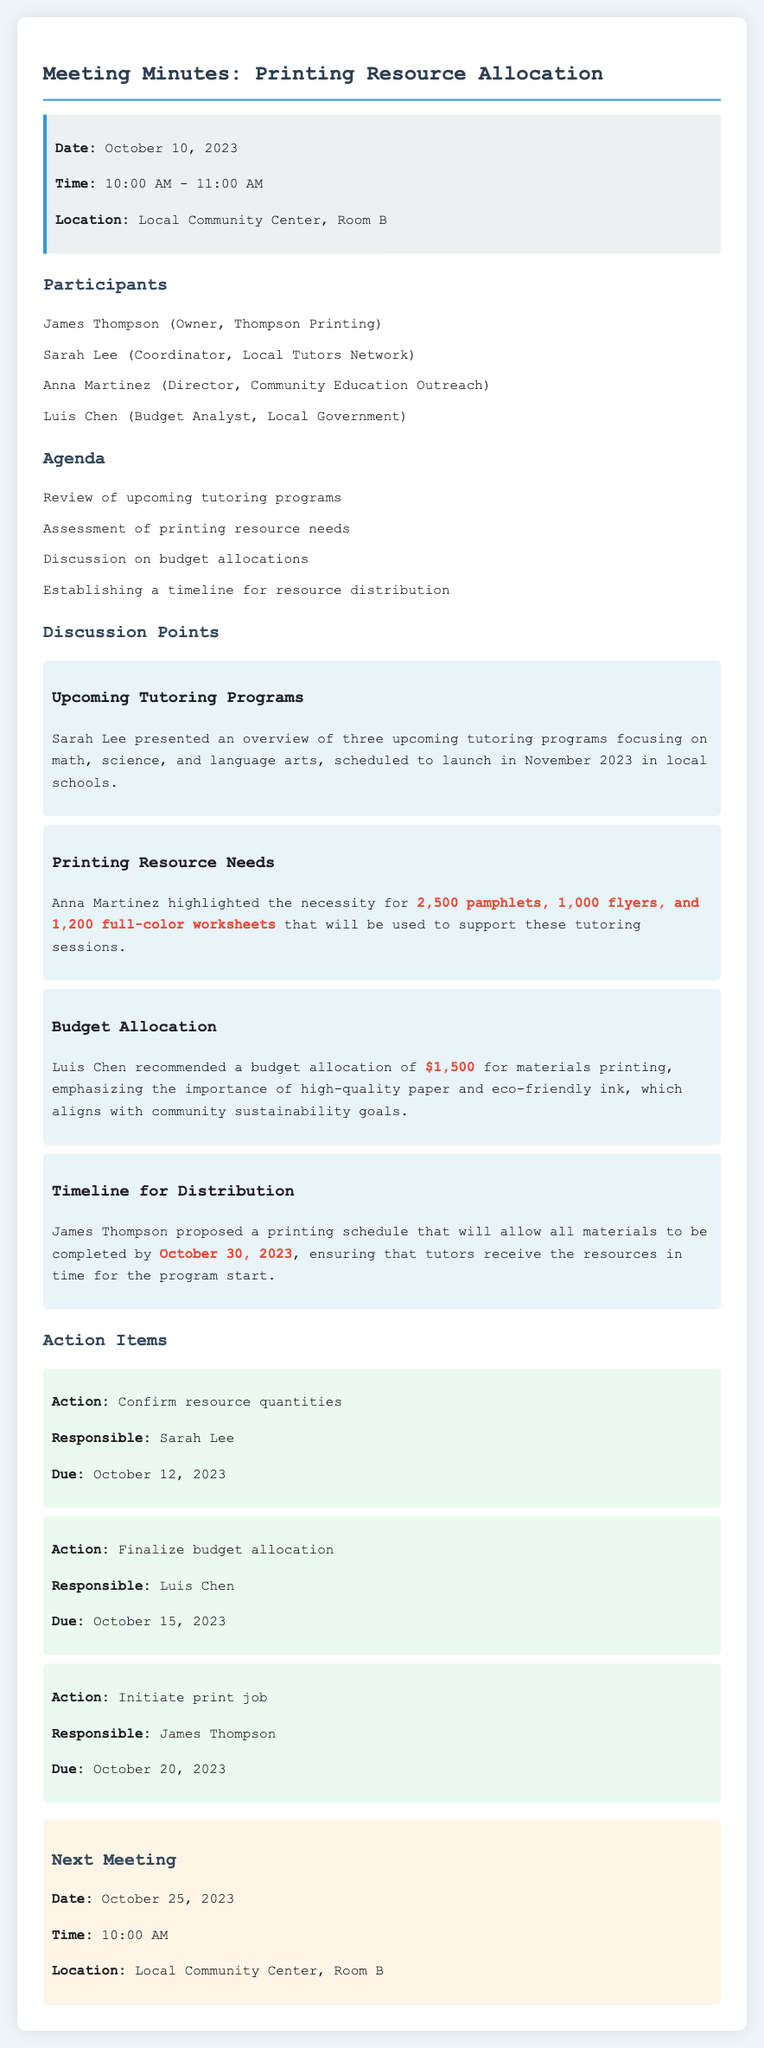what is the date of the meeting? The date of the meeting is explicitly stated in the info box at the top of the document.
Answer: October 10, 2023 who recommended the budget allocation? This information can be found in the discussion item concerning budget allocation, where Luis Chen makes the recommendation.
Answer: Luis Chen how many pamphlets are needed for the tutoring programs? The document explicitly states the required number of pamphlets in the section about printing resource needs.
Answer: 2,500 pamphlets what is the total budget allocation recommended? The budget allocation can be found in the discussion item regarding budget allocation, specifying the total amount suggested.
Answer: $1,500 when is the deadline for confirming resource quantities? This information can be found in the action items, detailing the due date for each action.
Answer: October 12, 2023 who is responsible for initiating the print job? The responsible person's name is mentioned in the action item for initiating the print job in the document.
Answer: James Thompson what is the location of the next meeting? The location details are provided at the end of the document, specifically under the next meeting section.
Answer: Local Community Center, Room B when should all materials be completed by? The proposed completion date for the materials is clearly stated in the timeline for distribution section.
Answer: October 30, 2023 what is the time of the next meeting? The time for the next meeting is specified under the next meeting section in the document.
Answer: 10:00 AM 